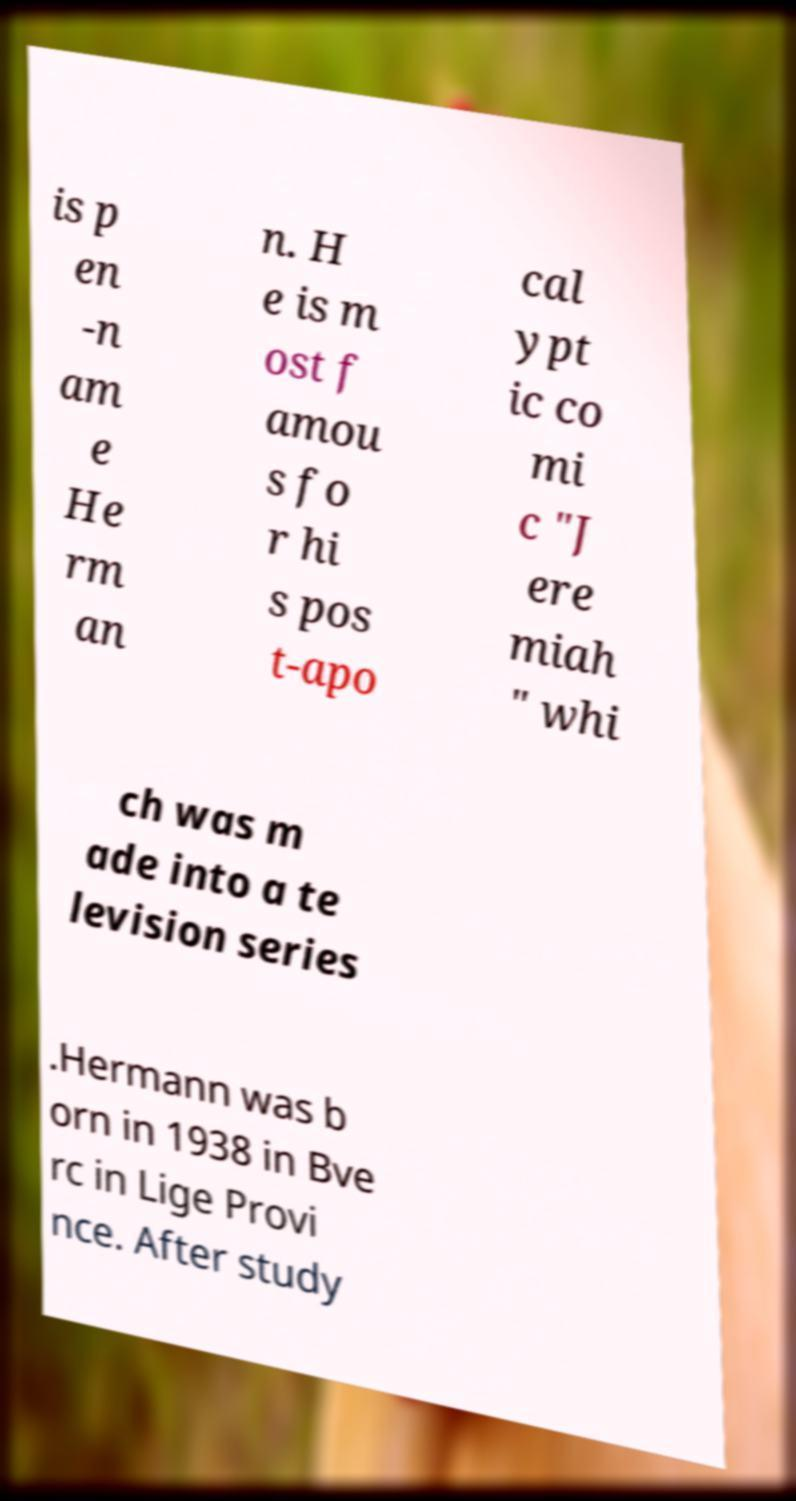Could you extract and type out the text from this image? is p en -n am e He rm an n. H e is m ost f amou s fo r hi s pos t-apo cal ypt ic co mi c "J ere miah " whi ch was m ade into a te levision series .Hermann was b orn in 1938 in Bve rc in Lige Provi nce. After study 